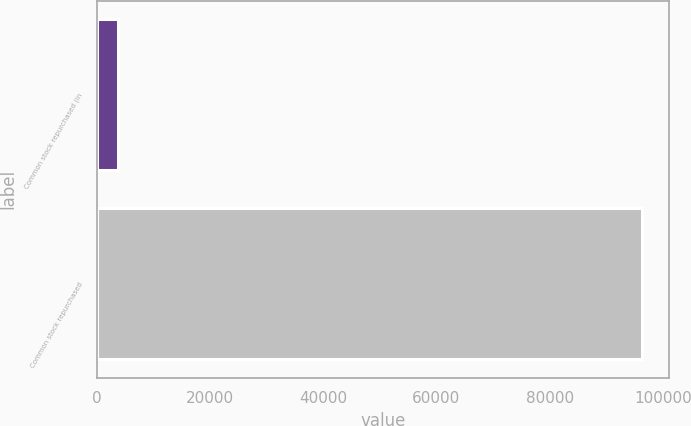Convert chart. <chart><loc_0><loc_0><loc_500><loc_500><bar_chart><fcel>Common stock repurchased (in<fcel>Common stock repurchased<nl><fcel>3678<fcel>96296<nl></chart> 